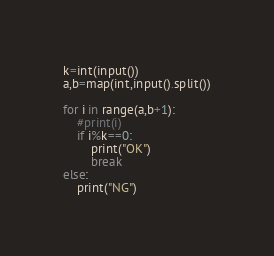<code> <loc_0><loc_0><loc_500><loc_500><_Python_>k=int(input())
a,b=map(int,input().split())

for i in range(a,b+1):
    #print(i)
    if i%k==0:
        print("OK")
        break
else:
    print("NG")</code> 